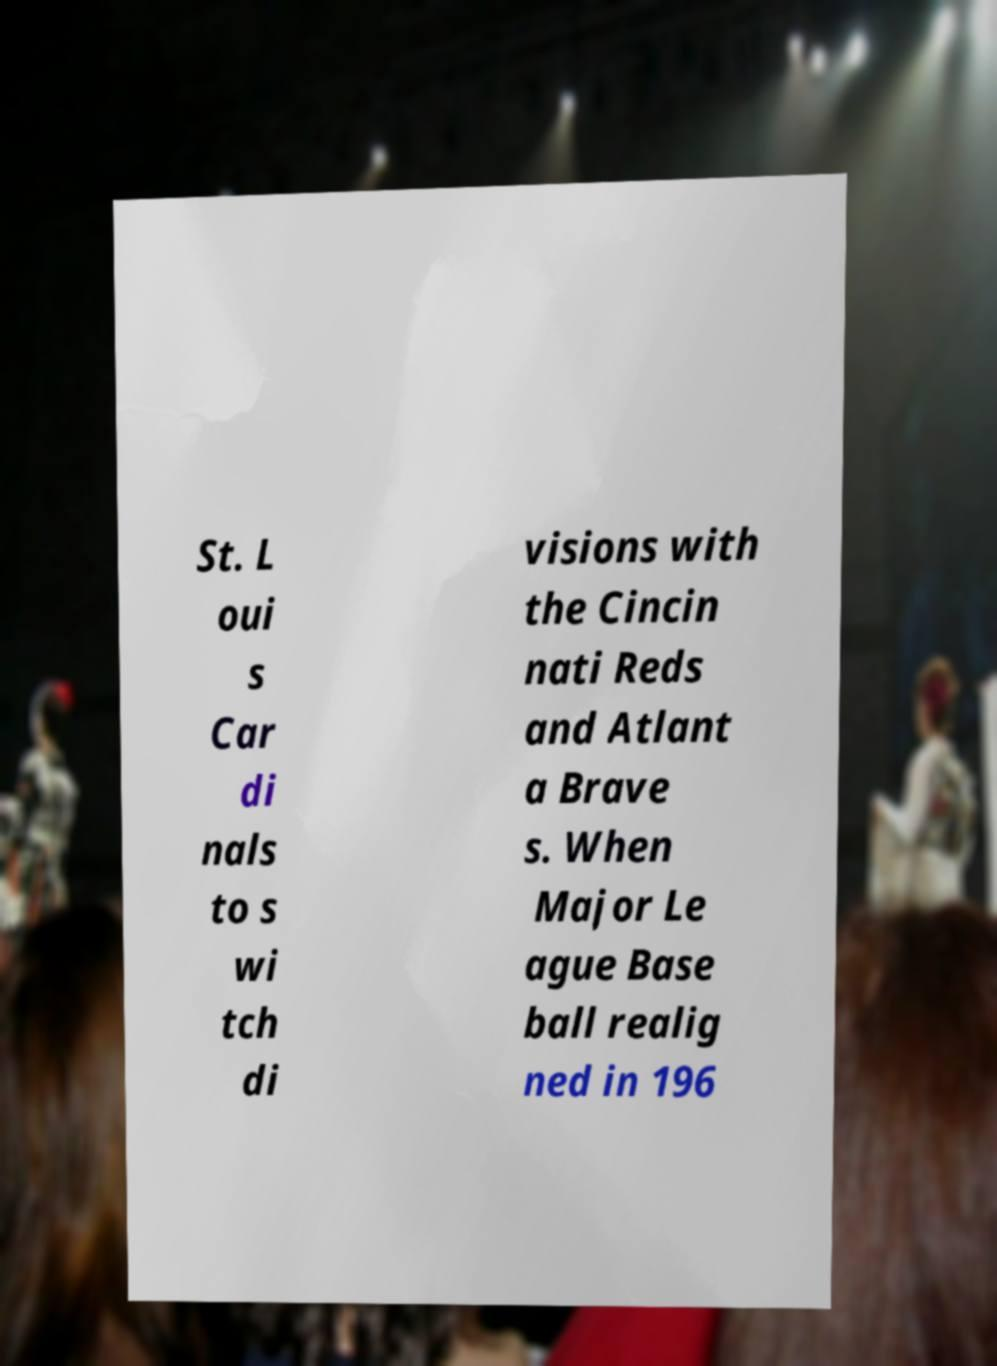Can you read and provide the text displayed in the image?This photo seems to have some interesting text. Can you extract and type it out for me? St. L oui s Car di nals to s wi tch di visions with the Cincin nati Reds and Atlant a Brave s. When Major Le ague Base ball realig ned in 196 